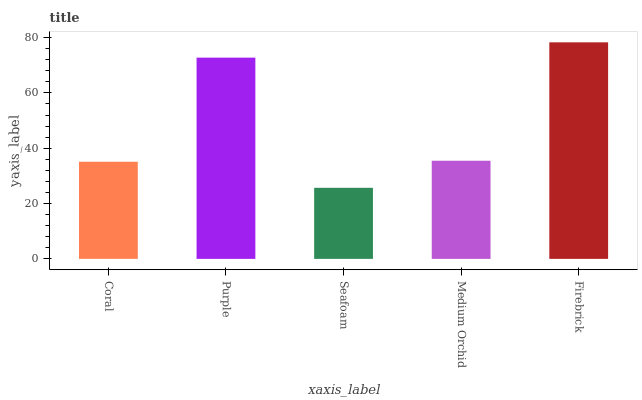Is Seafoam the minimum?
Answer yes or no. Yes. Is Firebrick the maximum?
Answer yes or no. Yes. Is Purple the minimum?
Answer yes or no. No. Is Purple the maximum?
Answer yes or no. No. Is Purple greater than Coral?
Answer yes or no. Yes. Is Coral less than Purple?
Answer yes or no. Yes. Is Coral greater than Purple?
Answer yes or no. No. Is Purple less than Coral?
Answer yes or no. No. Is Medium Orchid the high median?
Answer yes or no. Yes. Is Medium Orchid the low median?
Answer yes or no. Yes. Is Coral the high median?
Answer yes or no. No. Is Firebrick the low median?
Answer yes or no. No. 